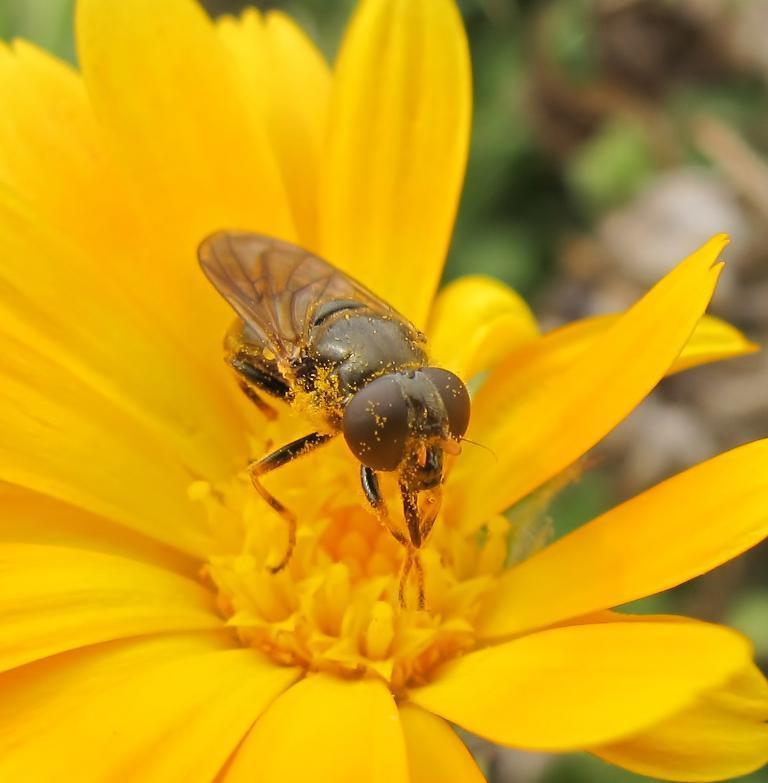What type of creature is present in the image? There is an insect in the image. Where is the insect located? The insect is on a yellow flower. Can you describe the background of the image? The background of the image is blurry. What type of silver object can be seen near the insect? There is no silver object present in the image. Can you describe the fairies that are interacting with the insect? There are no fairies present in the image; it only features an insect on a yellow flower. 